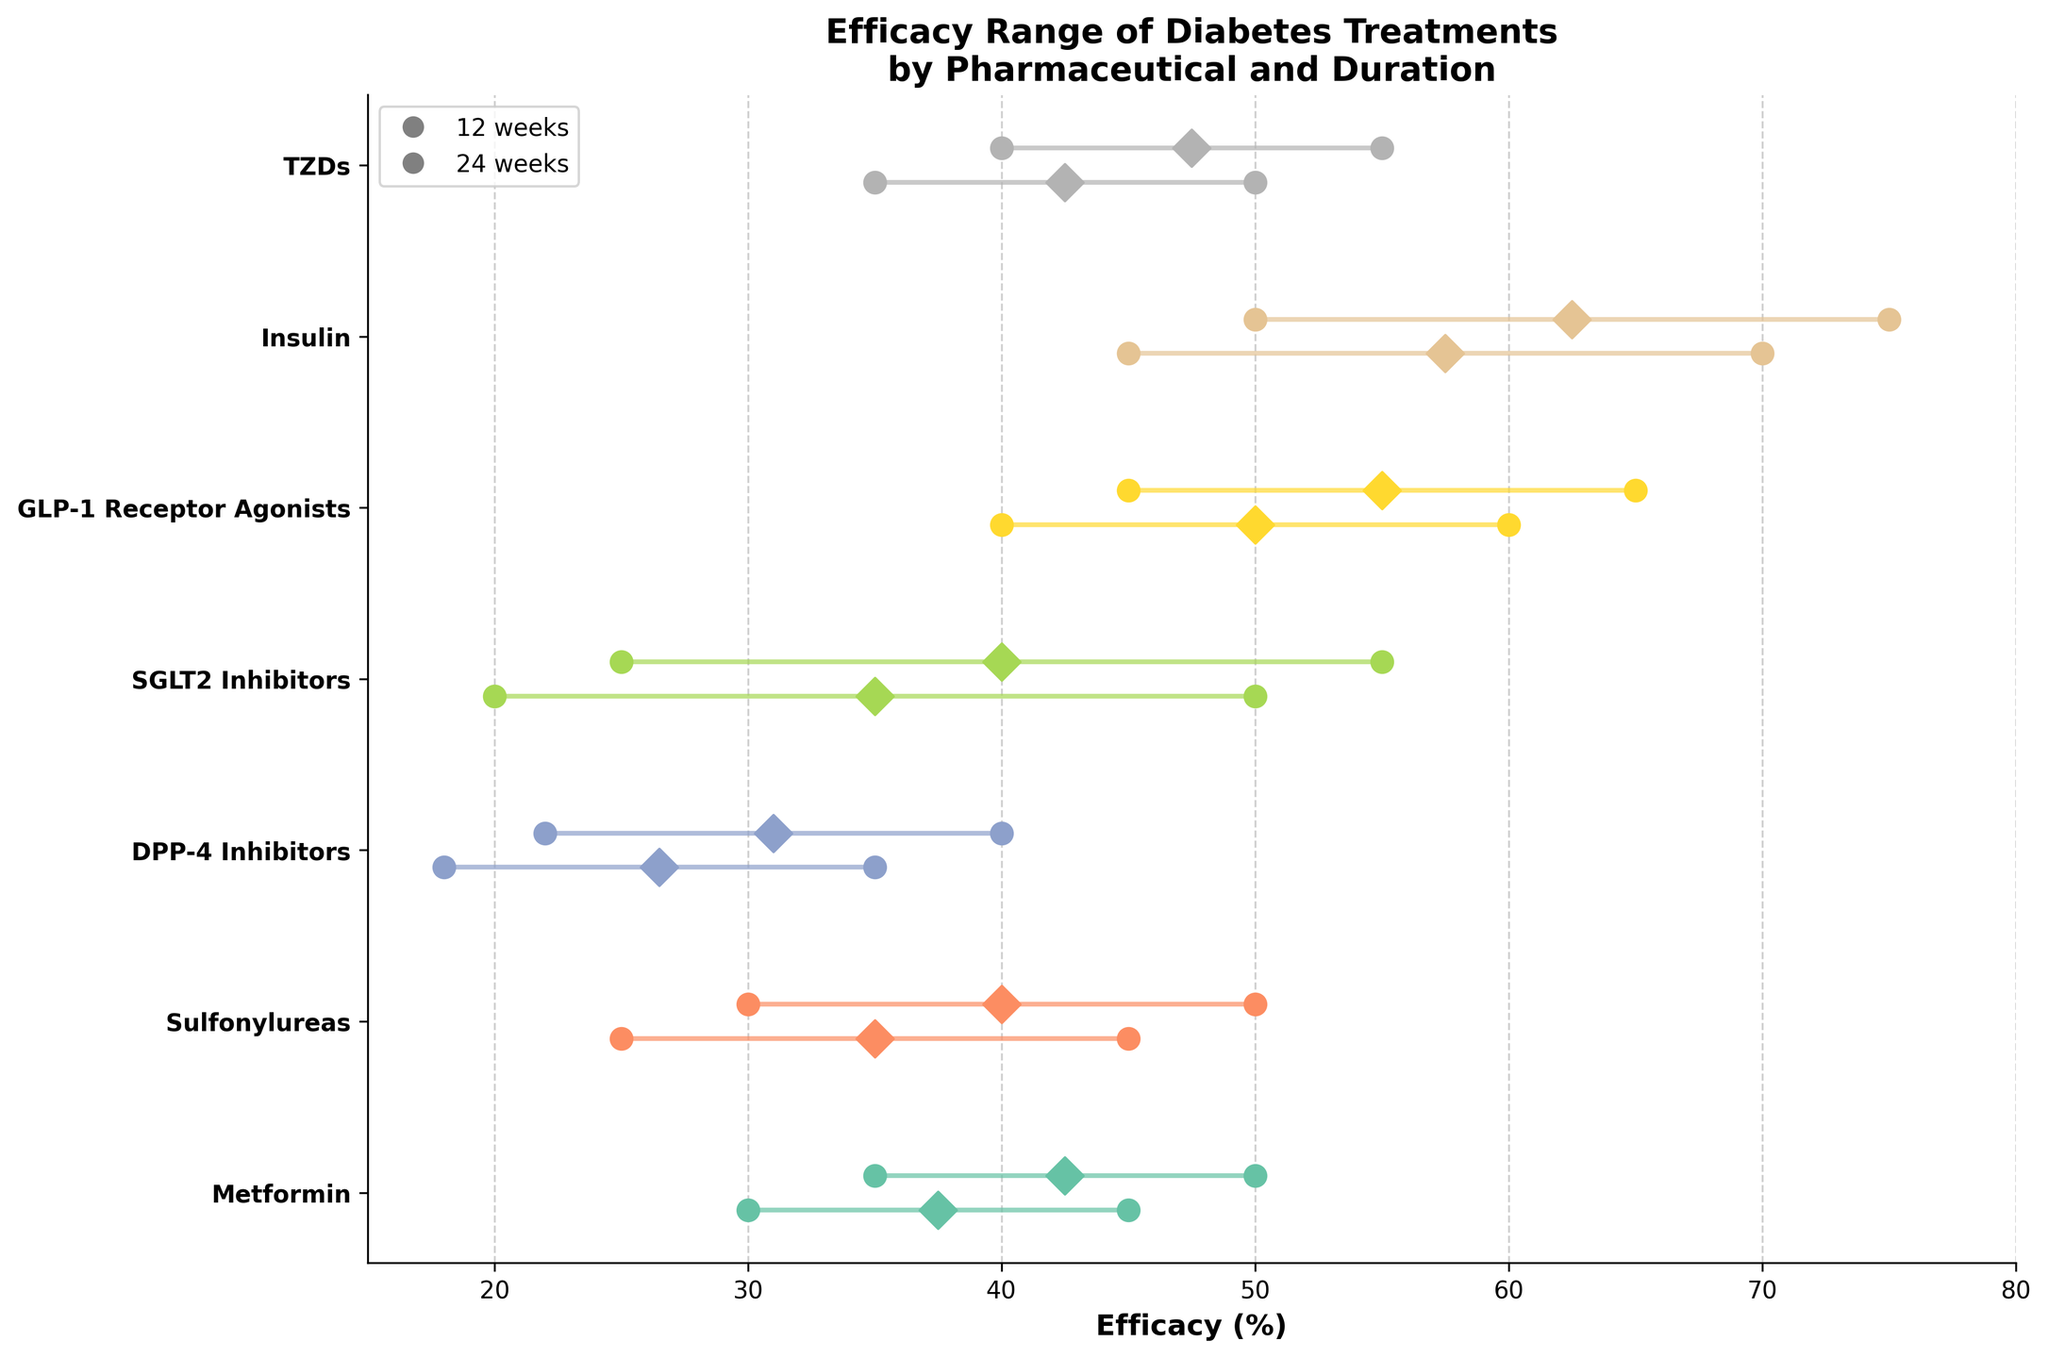What is the title of the plot? The title is usually located at the top of the plot. It provides the main information about what the plot represents. In this case, the title is "Efficacy Range of Diabetes Treatments by Pharmaceutical and Duration."
Answer: Efficacy Range of Diabetes Treatments by Pharmaceutical and Duration How many pharmaceuticals are analyzed in the plot? The number of pharmaceuticals can be determined by counting the y-tick labels on the y-axis. Each label represents a different pharmaceutical.
Answer: 7 Which pharmaceutical has the highest maximum efficacy at 12 weeks? By looking at the end points on the plot, Insulin has the highest maximum efficacy at 12 weeks, reaching up to 70%.
Answer: Insulin What is the efficacy range for Metformin at 24 weeks? The efficacy range can be identified by looking at the horizontal line for Metformin at the 24-week marker, which starts at 35% and ends at 50%.
Answer: 35% to 50% Which pharmaceutical shows an increase in minimum efficacy from 12 weeks to 24 weeks? By comparing the positions of the dots or lines for each pharmaceutical between the two durations, Metformin and Sulfonylureas show a clear increase in minimum efficacy.
Answer: Metformin and Sulfonylureas What is the average maximum efficacy of SGLT2 Inhibitors across both durations? For SGLT2 Inhibitors, identify the maximum efficacies at both 12 weeks (50%) and 24 weeks (55%). Then calculate the average: (50 + 55) / 2 = 52.5%.
Answer: 52.5% Which pharmaceutical has the longest efficacy range at 24 weeks? Look at the length of the horizontal lines for each pharmaceutical at the 24-week marker. Insulin has the longest efficacy range from 50% to 75%.
Answer: Insulin Does any pharmaceutical have the same efficacy range for both 12 and 24 weeks? By comparing the efficacy range lines for each pharmaceutical at both durations, no pharmaceutical has identical ranges for both durations.
Answer: No Which pharmaceutical saw the most significant increase in maximum efficacy from 12 weeks to 24 weeks? Calculate the difference in maximum efficacy for each pharmaceutical between the 12 and 24-week marks and find the greatest increase. Insulin increased from 70% at 12 weeks to 75% at 24 weeks, which is significant but not the largest increase. GLP-1 Receptor Agonists increased from 60% to 65%, which is also significant.
Answer: Insulin Which pharmaceutical has the highest minimum efficacy at 24 weeks? By looking at the starting points of the lines at 24 weeks, Insulin again has the highest minimum efficacy starting at 50%.
Answer: Insulin 